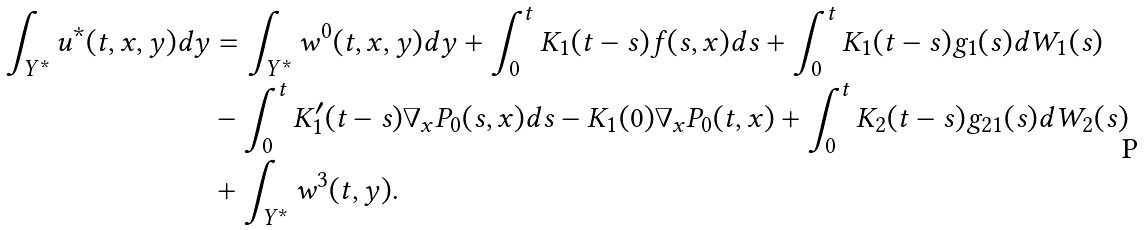<formula> <loc_0><loc_0><loc_500><loc_500>\int _ { Y ^ { * } } u ^ { * } ( t , x , y ) d y & = \int _ { Y ^ { * } } w ^ { 0 } ( t , x , y ) d y + \int _ { 0 } ^ { t } K _ { 1 } ( t - s ) f ( s , x ) d s + \int _ { 0 } ^ { t } K _ { 1 } ( t - s ) g _ { 1 } ( s ) d W _ { 1 } ( s ) \\ & - \int _ { 0 } ^ { t } K _ { 1 } ^ { \prime } ( t - s ) \nabla _ { x } P _ { 0 } ( s , x ) d s - K _ { 1 } ( 0 ) \nabla _ { x } P _ { 0 } ( t , x ) + \int _ { 0 } ^ { t } K _ { 2 } ( t - s ) g _ { 2 1 } ( s ) d W _ { 2 } ( s ) \\ & + \int _ { Y ^ { * } } w ^ { 3 } ( t , y ) .</formula> 